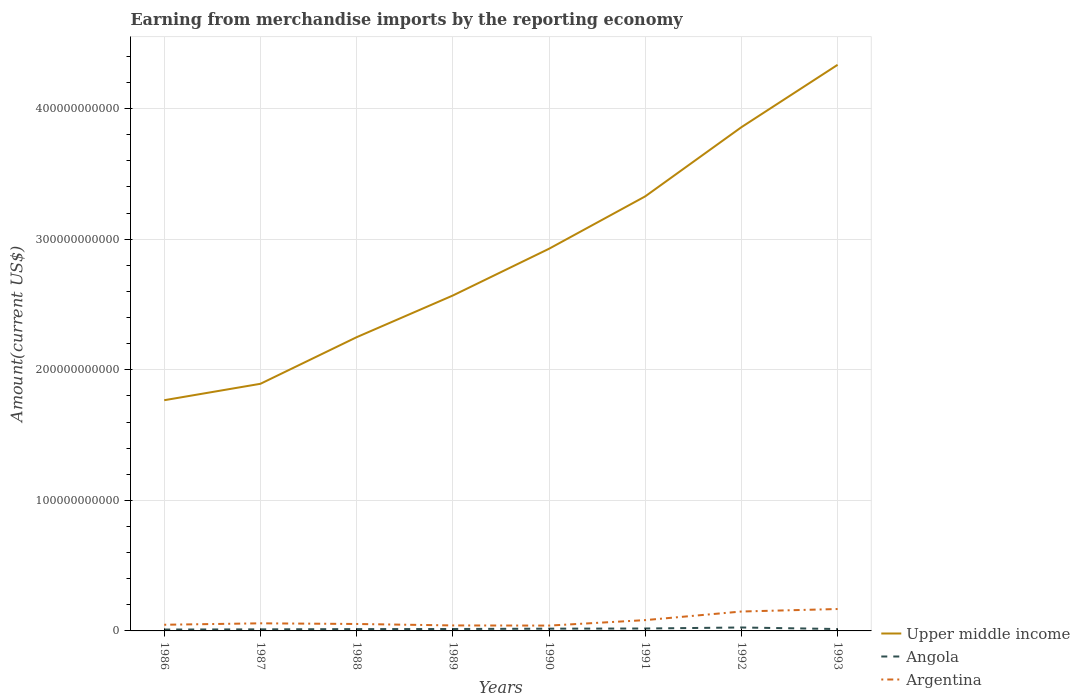How many different coloured lines are there?
Offer a very short reply. 3. Across all years, what is the maximum amount earned from merchandise imports in Angola?
Give a very brief answer. 1.06e+09. In which year was the amount earned from merchandise imports in Argentina maximum?
Ensure brevity in your answer.  1990. What is the total amount earned from merchandise imports in Upper middle income in the graph?
Make the answer very short. -6.76e+1. What is the difference between the highest and the second highest amount earned from merchandise imports in Argentina?
Provide a succinct answer. 1.27e+1. How many lines are there?
Provide a short and direct response. 3. What is the difference between two consecutive major ticks on the Y-axis?
Give a very brief answer. 1.00e+11. Are the values on the major ticks of Y-axis written in scientific E-notation?
Your answer should be compact. No. Does the graph contain any zero values?
Offer a very short reply. No. Does the graph contain grids?
Offer a very short reply. Yes. Where does the legend appear in the graph?
Offer a very short reply. Bottom right. How are the legend labels stacked?
Offer a very short reply. Vertical. What is the title of the graph?
Your response must be concise. Earning from merchandise imports by the reporting economy. Does "Peru" appear as one of the legend labels in the graph?
Offer a very short reply. No. What is the label or title of the X-axis?
Your response must be concise. Years. What is the label or title of the Y-axis?
Your answer should be compact. Amount(current US$). What is the Amount(current US$) in Upper middle income in 1986?
Ensure brevity in your answer.  1.77e+11. What is the Amount(current US$) in Angola in 1986?
Your response must be concise. 1.06e+09. What is the Amount(current US$) in Argentina in 1986?
Keep it short and to the point. 4.72e+09. What is the Amount(current US$) in Upper middle income in 1987?
Provide a succinct answer. 1.89e+11. What is the Amount(current US$) of Angola in 1987?
Provide a succinct answer. 1.20e+09. What is the Amount(current US$) of Argentina in 1987?
Your answer should be very brief. 5.82e+09. What is the Amount(current US$) in Upper middle income in 1988?
Keep it short and to the point. 2.25e+11. What is the Amount(current US$) in Angola in 1988?
Offer a terse response. 1.40e+09. What is the Amount(current US$) in Argentina in 1988?
Make the answer very short. 5.32e+09. What is the Amount(current US$) in Upper middle income in 1989?
Make the answer very short. 2.57e+11. What is the Amount(current US$) in Angola in 1989?
Offer a very short reply. 1.47e+09. What is the Amount(current US$) of Argentina in 1989?
Offer a terse response. 4.20e+09. What is the Amount(current US$) of Upper middle income in 1990?
Your answer should be very brief. 2.93e+11. What is the Amount(current US$) of Angola in 1990?
Provide a succinct answer. 1.72e+09. What is the Amount(current US$) of Argentina in 1990?
Offer a terse response. 4.08e+09. What is the Amount(current US$) in Upper middle income in 1991?
Your answer should be compact. 3.33e+11. What is the Amount(current US$) of Angola in 1991?
Ensure brevity in your answer.  1.85e+09. What is the Amount(current US$) in Argentina in 1991?
Ensure brevity in your answer.  8.28e+09. What is the Amount(current US$) of Upper middle income in 1992?
Provide a short and direct response. 3.86e+11. What is the Amount(current US$) of Angola in 1992?
Your answer should be very brief. 2.63e+09. What is the Amount(current US$) of Argentina in 1992?
Provide a short and direct response. 1.49e+1. What is the Amount(current US$) in Upper middle income in 1993?
Your response must be concise. 4.34e+11. What is the Amount(current US$) of Angola in 1993?
Your answer should be very brief. 1.45e+09. What is the Amount(current US$) in Argentina in 1993?
Provide a succinct answer. 1.68e+1. Across all years, what is the maximum Amount(current US$) of Upper middle income?
Provide a succinct answer. 4.34e+11. Across all years, what is the maximum Amount(current US$) in Angola?
Your response must be concise. 2.63e+09. Across all years, what is the maximum Amount(current US$) in Argentina?
Your answer should be compact. 1.68e+1. Across all years, what is the minimum Amount(current US$) of Upper middle income?
Offer a terse response. 1.77e+11. Across all years, what is the minimum Amount(current US$) in Angola?
Your answer should be compact. 1.06e+09. Across all years, what is the minimum Amount(current US$) in Argentina?
Give a very brief answer. 4.08e+09. What is the total Amount(current US$) in Upper middle income in the graph?
Provide a succinct answer. 2.29e+12. What is the total Amount(current US$) of Angola in the graph?
Provide a short and direct response. 1.28e+1. What is the total Amount(current US$) of Argentina in the graph?
Your answer should be very brief. 6.41e+1. What is the difference between the Amount(current US$) in Upper middle income in 1986 and that in 1987?
Keep it short and to the point. -1.26e+1. What is the difference between the Amount(current US$) of Angola in 1986 and that in 1987?
Offer a very short reply. -1.47e+08. What is the difference between the Amount(current US$) in Argentina in 1986 and that in 1987?
Make the answer very short. -1.09e+09. What is the difference between the Amount(current US$) in Upper middle income in 1986 and that in 1988?
Provide a succinct answer. -4.83e+1. What is the difference between the Amount(current US$) in Angola in 1986 and that in 1988?
Make the answer very short. -3.39e+08. What is the difference between the Amount(current US$) of Argentina in 1986 and that in 1988?
Your response must be concise. -5.95e+08. What is the difference between the Amount(current US$) of Upper middle income in 1986 and that in 1989?
Offer a terse response. -8.02e+1. What is the difference between the Amount(current US$) in Angola in 1986 and that in 1989?
Your answer should be compact. -4.11e+08. What is the difference between the Amount(current US$) in Argentina in 1986 and that in 1989?
Provide a succinct answer. 5.24e+08. What is the difference between the Amount(current US$) in Upper middle income in 1986 and that in 1990?
Your answer should be very brief. -1.16e+11. What is the difference between the Amount(current US$) in Angola in 1986 and that in 1990?
Offer a terse response. -6.65e+08. What is the difference between the Amount(current US$) in Argentina in 1986 and that in 1990?
Provide a short and direct response. 6.46e+08. What is the difference between the Amount(current US$) in Upper middle income in 1986 and that in 1991?
Provide a short and direct response. -1.56e+11. What is the difference between the Amount(current US$) in Angola in 1986 and that in 1991?
Offer a terse response. -7.89e+08. What is the difference between the Amount(current US$) in Argentina in 1986 and that in 1991?
Give a very brief answer. -3.55e+09. What is the difference between the Amount(current US$) in Upper middle income in 1986 and that in 1992?
Make the answer very short. -2.09e+11. What is the difference between the Amount(current US$) in Angola in 1986 and that in 1992?
Offer a terse response. -1.57e+09. What is the difference between the Amount(current US$) in Argentina in 1986 and that in 1992?
Ensure brevity in your answer.  -1.01e+1. What is the difference between the Amount(current US$) of Upper middle income in 1986 and that in 1993?
Your answer should be very brief. -2.57e+11. What is the difference between the Amount(current US$) of Angola in 1986 and that in 1993?
Offer a very short reply. -3.93e+08. What is the difference between the Amount(current US$) of Argentina in 1986 and that in 1993?
Keep it short and to the point. -1.20e+1. What is the difference between the Amount(current US$) in Upper middle income in 1987 and that in 1988?
Offer a terse response. -3.57e+1. What is the difference between the Amount(current US$) in Angola in 1987 and that in 1988?
Provide a short and direct response. -1.92e+08. What is the difference between the Amount(current US$) in Argentina in 1987 and that in 1988?
Offer a terse response. 4.99e+08. What is the difference between the Amount(current US$) of Upper middle income in 1987 and that in 1989?
Your response must be concise. -6.76e+1. What is the difference between the Amount(current US$) of Angola in 1987 and that in 1989?
Give a very brief answer. -2.64e+08. What is the difference between the Amount(current US$) of Argentina in 1987 and that in 1989?
Ensure brevity in your answer.  1.62e+09. What is the difference between the Amount(current US$) in Upper middle income in 1987 and that in 1990?
Make the answer very short. -1.03e+11. What is the difference between the Amount(current US$) of Angola in 1987 and that in 1990?
Make the answer very short. -5.18e+08. What is the difference between the Amount(current US$) of Argentina in 1987 and that in 1990?
Provide a succinct answer. 1.74e+09. What is the difference between the Amount(current US$) of Upper middle income in 1987 and that in 1991?
Make the answer very short. -1.44e+11. What is the difference between the Amount(current US$) in Angola in 1987 and that in 1991?
Offer a terse response. -6.42e+08. What is the difference between the Amount(current US$) of Argentina in 1987 and that in 1991?
Your answer should be very brief. -2.46e+09. What is the difference between the Amount(current US$) in Upper middle income in 1987 and that in 1992?
Make the answer very short. -1.97e+11. What is the difference between the Amount(current US$) of Angola in 1987 and that in 1992?
Provide a succinct answer. -1.43e+09. What is the difference between the Amount(current US$) of Argentina in 1987 and that in 1992?
Your answer should be very brief. -9.04e+09. What is the difference between the Amount(current US$) in Upper middle income in 1987 and that in 1993?
Offer a very short reply. -2.44e+11. What is the difference between the Amount(current US$) of Angola in 1987 and that in 1993?
Give a very brief answer. -2.46e+08. What is the difference between the Amount(current US$) of Argentina in 1987 and that in 1993?
Make the answer very short. -1.10e+1. What is the difference between the Amount(current US$) of Upper middle income in 1988 and that in 1989?
Provide a succinct answer. -3.19e+1. What is the difference between the Amount(current US$) of Angola in 1988 and that in 1989?
Provide a short and direct response. -7.23e+07. What is the difference between the Amount(current US$) in Argentina in 1988 and that in 1989?
Ensure brevity in your answer.  1.12e+09. What is the difference between the Amount(current US$) of Upper middle income in 1988 and that in 1990?
Your answer should be very brief. -6.77e+1. What is the difference between the Amount(current US$) of Angola in 1988 and that in 1990?
Make the answer very short. -3.27e+08. What is the difference between the Amount(current US$) of Argentina in 1988 and that in 1990?
Ensure brevity in your answer.  1.24e+09. What is the difference between the Amount(current US$) of Upper middle income in 1988 and that in 1991?
Provide a short and direct response. -1.08e+11. What is the difference between the Amount(current US$) in Angola in 1988 and that in 1991?
Your answer should be compact. -4.50e+08. What is the difference between the Amount(current US$) in Argentina in 1988 and that in 1991?
Give a very brief answer. -2.96e+09. What is the difference between the Amount(current US$) of Upper middle income in 1988 and that in 1992?
Provide a succinct answer. -1.61e+11. What is the difference between the Amount(current US$) of Angola in 1988 and that in 1992?
Keep it short and to the point. -1.24e+09. What is the difference between the Amount(current US$) of Argentina in 1988 and that in 1992?
Give a very brief answer. -9.54e+09. What is the difference between the Amount(current US$) of Upper middle income in 1988 and that in 1993?
Your answer should be compact. -2.09e+11. What is the difference between the Amount(current US$) of Angola in 1988 and that in 1993?
Your answer should be very brief. -5.45e+07. What is the difference between the Amount(current US$) in Argentina in 1988 and that in 1993?
Give a very brief answer. -1.15e+1. What is the difference between the Amount(current US$) in Upper middle income in 1989 and that in 1990?
Your answer should be compact. -3.58e+1. What is the difference between the Amount(current US$) in Angola in 1989 and that in 1990?
Your answer should be compact. -2.54e+08. What is the difference between the Amount(current US$) of Argentina in 1989 and that in 1990?
Ensure brevity in your answer.  1.22e+08. What is the difference between the Amount(current US$) of Upper middle income in 1989 and that in 1991?
Provide a short and direct response. -7.59e+1. What is the difference between the Amount(current US$) of Angola in 1989 and that in 1991?
Offer a terse response. -3.78e+08. What is the difference between the Amount(current US$) in Argentina in 1989 and that in 1991?
Provide a succinct answer. -4.07e+09. What is the difference between the Amount(current US$) in Upper middle income in 1989 and that in 1992?
Your answer should be compact. -1.29e+11. What is the difference between the Amount(current US$) in Angola in 1989 and that in 1992?
Your answer should be compact. -1.16e+09. What is the difference between the Amount(current US$) of Argentina in 1989 and that in 1992?
Keep it short and to the point. -1.07e+1. What is the difference between the Amount(current US$) of Upper middle income in 1989 and that in 1993?
Keep it short and to the point. -1.77e+11. What is the difference between the Amount(current US$) of Angola in 1989 and that in 1993?
Your response must be concise. 1.78e+07. What is the difference between the Amount(current US$) of Argentina in 1989 and that in 1993?
Ensure brevity in your answer.  -1.26e+1. What is the difference between the Amount(current US$) in Upper middle income in 1990 and that in 1991?
Keep it short and to the point. -4.01e+1. What is the difference between the Amount(current US$) in Angola in 1990 and that in 1991?
Your response must be concise. -1.24e+08. What is the difference between the Amount(current US$) of Argentina in 1990 and that in 1991?
Your answer should be very brief. -4.20e+09. What is the difference between the Amount(current US$) of Upper middle income in 1990 and that in 1992?
Make the answer very short. -9.31e+1. What is the difference between the Amount(current US$) in Angola in 1990 and that in 1992?
Provide a short and direct response. -9.10e+08. What is the difference between the Amount(current US$) in Argentina in 1990 and that in 1992?
Your answer should be very brief. -1.08e+1. What is the difference between the Amount(current US$) in Upper middle income in 1990 and that in 1993?
Make the answer very short. -1.41e+11. What is the difference between the Amount(current US$) of Angola in 1990 and that in 1993?
Make the answer very short. 2.72e+08. What is the difference between the Amount(current US$) in Argentina in 1990 and that in 1993?
Offer a terse response. -1.27e+1. What is the difference between the Amount(current US$) of Upper middle income in 1991 and that in 1992?
Make the answer very short. -5.30e+1. What is the difference between the Amount(current US$) in Angola in 1991 and that in 1992?
Your response must be concise. -7.86e+08. What is the difference between the Amount(current US$) in Argentina in 1991 and that in 1992?
Offer a terse response. -6.59e+09. What is the difference between the Amount(current US$) in Upper middle income in 1991 and that in 1993?
Ensure brevity in your answer.  -1.01e+11. What is the difference between the Amount(current US$) in Angola in 1991 and that in 1993?
Give a very brief answer. 3.96e+08. What is the difference between the Amount(current US$) in Argentina in 1991 and that in 1993?
Ensure brevity in your answer.  -8.50e+09. What is the difference between the Amount(current US$) of Upper middle income in 1992 and that in 1993?
Offer a terse response. -4.78e+1. What is the difference between the Amount(current US$) of Angola in 1992 and that in 1993?
Offer a very short reply. 1.18e+09. What is the difference between the Amount(current US$) of Argentina in 1992 and that in 1993?
Your response must be concise. -1.91e+09. What is the difference between the Amount(current US$) of Upper middle income in 1986 and the Amount(current US$) of Angola in 1987?
Offer a very short reply. 1.75e+11. What is the difference between the Amount(current US$) of Upper middle income in 1986 and the Amount(current US$) of Argentina in 1987?
Your response must be concise. 1.71e+11. What is the difference between the Amount(current US$) in Angola in 1986 and the Amount(current US$) in Argentina in 1987?
Offer a terse response. -4.76e+09. What is the difference between the Amount(current US$) of Upper middle income in 1986 and the Amount(current US$) of Angola in 1988?
Provide a short and direct response. 1.75e+11. What is the difference between the Amount(current US$) of Upper middle income in 1986 and the Amount(current US$) of Argentina in 1988?
Make the answer very short. 1.71e+11. What is the difference between the Amount(current US$) of Angola in 1986 and the Amount(current US$) of Argentina in 1988?
Provide a succinct answer. -4.26e+09. What is the difference between the Amount(current US$) in Upper middle income in 1986 and the Amount(current US$) in Angola in 1989?
Ensure brevity in your answer.  1.75e+11. What is the difference between the Amount(current US$) in Upper middle income in 1986 and the Amount(current US$) in Argentina in 1989?
Offer a terse response. 1.72e+11. What is the difference between the Amount(current US$) of Angola in 1986 and the Amount(current US$) of Argentina in 1989?
Make the answer very short. -3.14e+09. What is the difference between the Amount(current US$) of Upper middle income in 1986 and the Amount(current US$) of Angola in 1990?
Make the answer very short. 1.75e+11. What is the difference between the Amount(current US$) of Upper middle income in 1986 and the Amount(current US$) of Argentina in 1990?
Keep it short and to the point. 1.73e+11. What is the difference between the Amount(current US$) in Angola in 1986 and the Amount(current US$) in Argentina in 1990?
Keep it short and to the point. -3.02e+09. What is the difference between the Amount(current US$) in Upper middle income in 1986 and the Amount(current US$) in Angola in 1991?
Keep it short and to the point. 1.75e+11. What is the difference between the Amount(current US$) in Upper middle income in 1986 and the Amount(current US$) in Argentina in 1991?
Your response must be concise. 1.68e+11. What is the difference between the Amount(current US$) in Angola in 1986 and the Amount(current US$) in Argentina in 1991?
Your response must be concise. -7.22e+09. What is the difference between the Amount(current US$) in Upper middle income in 1986 and the Amount(current US$) in Angola in 1992?
Keep it short and to the point. 1.74e+11. What is the difference between the Amount(current US$) in Upper middle income in 1986 and the Amount(current US$) in Argentina in 1992?
Your answer should be compact. 1.62e+11. What is the difference between the Amount(current US$) in Angola in 1986 and the Amount(current US$) in Argentina in 1992?
Ensure brevity in your answer.  -1.38e+1. What is the difference between the Amount(current US$) in Upper middle income in 1986 and the Amount(current US$) in Angola in 1993?
Offer a very short reply. 1.75e+11. What is the difference between the Amount(current US$) of Upper middle income in 1986 and the Amount(current US$) of Argentina in 1993?
Provide a succinct answer. 1.60e+11. What is the difference between the Amount(current US$) of Angola in 1986 and the Amount(current US$) of Argentina in 1993?
Your answer should be compact. -1.57e+1. What is the difference between the Amount(current US$) in Upper middle income in 1987 and the Amount(current US$) in Angola in 1988?
Your answer should be compact. 1.88e+11. What is the difference between the Amount(current US$) in Upper middle income in 1987 and the Amount(current US$) in Argentina in 1988?
Your answer should be compact. 1.84e+11. What is the difference between the Amount(current US$) in Angola in 1987 and the Amount(current US$) in Argentina in 1988?
Provide a succinct answer. -4.11e+09. What is the difference between the Amount(current US$) of Upper middle income in 1987 and the Amount(current US$) of Angola in 1989?
Keep it short and to the point. 1.88e+11. What is the difference between the Amount(current US$) of Upper middle income in 1987 and the Amount(current US$) of Argentina in 1989?
Keep it short and to the point. 1.85e+11. What is the difference between the Amount(current US$) of Angola in 1987 and the Amount(current US$) of Argentina in 1989?
Your answer should be very brief. -3.00e+09. What is the difference between the Amount(current US$) of Upper middle income in 1987 and the Amount(current US$) of Angola in 1990?
Provide a short and direct response. 1.88e+11. What is the difference between the Amount(current US$) of Upper middle income in 1987 and the Amount(current US$) of Argentina in 1990?
Provide a succinct answer. 1.85e+11. What is the difference between the Amount(current US$) of Angola in 1987 and the Amount(current US$) of Argentina in 1990?
Offer a terse response. -2.87e+09. What is the difference between the Amount(current US$) of Upper middle income in 1987 and the Amount(current US$) of Angola in 1991?
Offer a very short reply. 1.87e+11. What is the difference between the Amount(current US$) of Upper middle income in 1987 and the Amount(current US$) of Argentina in 1991?
Your answer should be compact. 1.81e+11. What is the difference between the Amount(current US$) of Angola in 1987 and the Amount(current US$) of Argentina in 1991?
Your response must be concise. -7.07e+09. What is the difference between the Amount(current US$) of Upper middle income in 1987 and the Amount(current US$) of Angola in 1992?
Provide a short and direct response. 1.87e+11. What is the difference between the Amount(current US$) of Upper middle income in 1987 and the Amount(current US$) of Argentina in 1992?
Keep it short and to the point. 1.74e+11. What is the difference between the Amount(current US$) of Angola in 1987 and the Amount(current US$) of Argentina in 1992?
Offer a terse response. -1.37e+1. What is the difference between the Amount(current US$) in Upper middle income in 1987 and the Amount(current US$) in Angola in 1993?
Your response must be concise. 1.88e+11. What is the difference between the Amount(current US$) in Upper middle income in 1987 and the Amount(current US$) in Argentina in 1993?
Provide a succinct answer. 1.72e+11. What is the difference between the Amount(current US$) of Angola in 1987 and the Amount(current US$) of Argentina in 1993?
Ensure brevity in your answer.  -1.56e+1. What is the difference between the Amount(current US$) in Upper middle income in 1988 and the Amount(current US$) in Angola in 1989?
Make the answer very short. 2.23e+11. What is the difference between the Amount(current US$) of Upper middle income in 1988 and the Amount(current US$) of Argentina in 1989?
Your response must be concise. 2.21e+11. What is the difference between the Amount(current US$) of Angola in 1988 and the Amount(current US$) of Argentina in 1989?
Offer a very short reply. -2.80e+09. What is the difference between the Amount(current US$) in Upper middle income in 1988 and the Amount(current US$) in Angola in 1990?
Your answer should be very brief. 2.23e+11. What is the difference between the Amount(current US$) of Upper middle income in 1988 and the Amount(current US$) of Argentina in 1990?
Provide a succinct answer. 2.21e+11. What is the difference between the Amount(current US$) of Angola in 1988 and the Amount(current US$) of Argentina in 1990?
Your response must be concise. -2.68e+09. What is the difference between the Amount(current US$) in Upper middle income in 1988 and the Amount(current US$) in Angola in 1991?
Your answer should be very brief. 2.23e+11. What is the difference between the Amount(current US$) of Upper middle income in 1988 and the Amount(current US$) of Argentina in 1991?
Your response must be concise. 2.17e+11. What is the difference between the Amount(current US$) of Angola in 1988 and the Amount(current US$) of Argentina in 1991?
Offer a very short reply. -6.88e+09. What is the difference between the Amount(current US$) of Upper middle income in 1988 and the Amount(current US$) of Angola in 1992?
Provide a short and direct response. 2.22e+11. What is the difference between the Amount(current US$) in Upper middle income in 1988 and the Amount(current US$) in Argentina in 1992?
Your answer should be very brief. 2.10e+11. What is the difference between the Amount(current US$) of Angola in 1988 and the Amount(current US$) of Argentina in 1992?
Give a very brief answer. -1.35e+1. What is the difference between the Amount(current US$) in Upper middle income in 1988 and the Amount(current US$) in Angola in 1993?
Keep it short and to the point. 2.23e+11. What is the difference between the Amount(current US$) of Upper middle income in 1988 and the Amount(current US$) of Argentina in 1993?
Offer a terse response. 2.08e+11. What is the difference between the Amount(current US$) of Angola in 1988 and the Amount(current US$) of Argentina in 1993?
Provide a short and direct response. -1.54e+1. What is the difference between the Amount(current US$) in Upper middle income in 1989 and the Amount(current US$) in Angola in 1990?
Provide a short and direct response. 2.55e+11. What is the difference between the Amount(current US$) of Upper middle income in 1989 and the Amount(current US$) of Argentina in 1990?
Provide a short and direct response. 2.53e+11. What is the difference between the Amount(current US$) in Angola in 1989 and the Amount(current US$) in Argentina in 1990?
Provide a succinct answer. -2.61e+09. What is the difference between the Amount(current US$) in Upper middle income in 1989 and the Amount(current US$) in Angola in 1991?
Provide a short and direct response. 2.55e+11. What is the difference between the Amount(current US$) in Upper middle income in 1989 and the Amount(current US$) in Argentina in 1991?
Your answer should be compact. 2.49e+11. What is the difference between the Amount(current US$) in Angola in 1989 and the Amount(current US$) in Argentina in 1991?
Your response must be concise. -6.81e+09. What is the difference between the Amount(current US$) in Upper middle income in 1989 and the Amount(current US$) in Angola in 1992?
Provide a short and direct response. 2.54e+11. What is the difference between the Amount(current US$) of Upper middle income in 1989 and the Amount(current US$) of Argentina in 1992?
Offer a very short reply. 2.42e+11. What is the difference between the Amount(current US$) of Angola in 1989 and the Amount(current US$) of Argentina in 1992?
Your response must be concise. -1.34e+1. What is the difference between the Amount(current US$) of Upper middle income in 1989 and the Amount(current US$) of Angola in 1993?
Keep it short and to the point. 2.55e+11. What is the difference between the Amount(current US$) of Upper middle income in 1989 and the Amount(current US$) of Argentina in 1993?
Make the answer very short. 2.40e+11. What is the difference between the Amount(current US$) of Angola in 1989 and the Amount(current US$) of Argentina in 1993?
Offer a very short reply. -1.53e+1. What is the difference between the Amount(current US$) of Upper middle income in 1990 and the Amount(current US$) of Angola in 1991?
Provide a short and direct response. 2.91e+11. What is the difference between the Amount(current US$) of Upper middle income in 1990 and the Amount(current US$) of Argentina in 1991?
Ensure brevity in your answer.  2.84e+11. What is the difference between the Amount(current US$) of Angola in 1990 and the Amount(current US$) of Argentina in 1991?
Give a very brief answer. -6.55e+09. What is the difference between the Amount(current US$) in Upper middle income in 1990 and the Amount(current US$) in Angola in 1992?
Your answer should be very brief. 2.90e+11. What is the difference between the Amount(current US$) in Upper middle income in 1990 and the Amount(current US$) in Argentina in 1992?
Ensure brevity in your answer.  2.78e+11. What is the difference between the Amount(current US$) of Angola in 1990 and the Amount(current US$) of Argentina in 1992?
Your answer should be very brief. -1.31e+1. What is the difference between the Amount(current US$) of Upper middle income in 1990 and the Amount(current US$) of Angola in 1993?
Offer a terse response. 2.91e+11. What is the difference between the Amount(current US$) of Upper middle income in 1990 and the Amount(current US$) of Argentina in 1993?
Give a very brief answer. 2.76e+11. What is the difference between the Amount(current US$) of Angola in 1990 and the Amount(current US$) of Argentina in 1993?
Offer a terse response. -1.51e+1. What is the difference between the Amount(current US$) in Upper middle income in 1991 and the Amount(current US$) in Angola in 1992?
Make the answer very short. 3.30e+11. What is the difference between the Amount(current US$) in Upper middle income in 1991 and the Amount(current US$) in Argentina in 1992?
Give a very brief answer. 3.18e+11. What is the difference between the Amount(current US$) of Angola in 1991 and the Amount(current US$) of Argentina in 1992?
Your answer should be compact. -1.30e+1. What is the difference between the Amount(current US$) of Upper middle income in 1991 and the Amount(current US$) of Angola in 1993?
Your response must be concise. 3.31e+11. What is the difference between the Amount(current US$) of Upper middle income in 1991 and the Amount(current US$) of Argentina in 1993?
Give a very brief answer. 3.16e+11. What is the difference between the Amount(current US$) of Angola in 1991 and the Amount(current US$) of Argentina in 1993?
Keep it short and to the point. -1.49e+1. What is the difference between the Amount(current US$) in Upper middle income in 1992 and the Amount(current US$) in Angola in 1993?
Your answer should be compact. 3.84e+11. What is the difference between the Amount(current US$) of Upper middle income in 1992 and the Amount(current US$) of Argentina in 1993?
Provide a short and direct response. 3.69e+11. What is the difference between the Amount(current US$) in Angola in 1992 and the Amount(current US$) in Argentina in 1993?
Your response must be concise. -1.41e+1. What is the average Amount(current US$) in Upper middle income per year?
Give a very brief answer. 2.87e+11. What is the average Amount(current US$) of Angola per year?
Offer a terse response. 1.60e+09. What is the average Amount(current US$) in Argentina per year?
Make the answer very short. 8.01e+09. In the year 1986, what is the difference between the Amount(current US$) in Upper middle income and Amount(current US$) in Angola?
Give a very brief answer. 1.76e+11. In the year 1986, what is the difference between the Amount(current US$) in Upper middle income and Amount(current US$) in Argentina?
Offer a very short reply. 1.72e+11. In the year 1986, what is the difference between the Amount(current US$) of Angola and Amount(current US$) of Argentina?
Make the answer very short. -3.67e+09. In the year 1987, what is the difference between the Amount(current US$) of Upper middle income and Amount(current US$) of Angola?
Offer a very short reply. 1.88e+11. In the year 1987, what is the difference between the Amount(current US$) of Upper middle income and Amount(current US$) of Argentina?
Offer a terse response. 1.83e+11. In the year 1987, what is the difference between the Amount(current US$) of Angola and Amount(current US$) of Argentina?
Your answer should be very brief. -4.61e+09. In the year 1988, what is the difference between the Amount(current US$) in Upper middle income and Amount(current US$) in Angola?
Keep it short and to the point. 2.24e+11. In the year 1988, what is the difference between the Amount(current US$) in Upper middle income and Amount(current US$) in Argentina?
Your answer should be very brief. 2.20e+11. In the year 1988, what is the difference between the Amount(current US$) of Angola and Amount(current US$) of Argentina?
Make the answer very short. -3.92e+09. In the year 1989, what is the difference between the Amount(current US$) in Upper middle income and Amount(current US$) in Angola?
Provide a short and direct response. 2.55e+11. In the year 1989, what is the difference between the Amount(current US$) in Upper middle income and Amount(current US$) in Argentina?
Provide a succinct answer. 2.53e+11. In the year 1989, what is the difference between the Amount(current US$) in Angola and Amount(current US$) in Argentina?
Offer a very short reply. -2.73e+09. In the year 1990, what is the difference between the Amount(current US$) in Upper middle income and Amount(current US$) in Angola?
Your response must be concise. 2.91e+11. In the year 1990, what is the difference between the Amount(current US$) in Upper middle income and Amount(current US$) in Argentina?
Make the answer very short. 2.89e+11. In the year 1990, what is the difference between the Amount(current US$) in Angola and Amount(current US$) in Argentina?
Offer a terse response. -2.36e+09. In the year 1991, what is the difference between the Amount(current US$) in Upper middle income and Amount(current US$) in Angola?
Offer a terse response. 3.31e+11. In the year 1991, what is the difference between the Amount(current US$) of Upper middle income and Amount(current US$) of Argentina?
Keep it short and to the point. 3.25e+11. In the year 1991, what is the difference between the Amount(current US$) in Angola and Amount(current US$) in Argentina?
Your answer should be very brief. -6.43e+09. In the year 1992, what is the difference between the Amount(current US$) of Upper middle income and Amount(current US$) of Angola?
Offer a terse response. 3.83e+11. In the year 1992, what is the difference between the Amount(current US$) of Upper middle income and Amount(current US$) of Argentina?
Give a very brief answer. 3.71e+11. In the year 1992, what is the difference between the Amount(current US$) of Angola and Amount(current US$) of Argentina?
Ensure brevity in your answer.  -1.22e+1. In the year 1993, what is the difference between the Amount(current US$) in Upper middle income and Amount(current US$) in Angola?
Make the answer very short. 4.32e+11. In the year 1993, what is the difference between the Amount(current US$) in Upper middle income and Amount(current US$) in Argentina?
Ensure brevity in your answer.  4.17e+11. In the year 1993, what is the difference between the Amount(current US$) in Angola and Amount(current US$) in Argentina?
Your response must be concise. -1.53e+1. What is the ratio of the Amount(current US$) of Upper middle income in 1986 to that in 1987?
Offer a very short reply. 0.93. What is the ratio of the Amount(current US$) in Angola in 1986 to that in 1987?
Your answer should be very brief. 0.88. What is the ratio of the Amount(current US$) in Argentina in 1986 to that in 1987?
Keep it short and to the point. 0.81. What is the ratio of the Amount(current US$) of Upper middle income in 1986 to that in 1988?
Offer a very short reply. 0.79. What is the ratio of the Amount(current US$) of Angola in 1986 to that in 1988?
Offer a terse response. 0.76. What is the ratio of the Amount(current US$) in Argentina in 1986 to that in 1988?
Offer a very short reply. 0.89. What is the ratio of the Amount(current US$) in Upper middle income in 1986 to that in 1989?
Make the answer very short. 0.69. What is the ratio of the Amount(current US$) in Angola in 1986 to that in 1989?
Make the answer very short. 0.72. What is the ratio of the Amount(current US$) of Argentina in 1986 to that in 1989?
Offer a very short reply. 1.12. What is the ratio of the Amount(current US$) in Upper middle income in 1986 to that in 1990?
Keep it short and to the point. 0.6. What is the ratio of the Amount(current US$) of Angola in 1986 to that in 1990?
Provide a succinct answer. 0.61. What is the ratio of the Amount(current US$) in Argentina in 1986 to that in 1990?
Provide a short and direct response. 1.16. What is the ratio of the Amount(current US$) in Upper middle income in 1986 to that in 1991?
Provide a succinct answer. 0.53. What is the ratio of the Amount(current US$) in Angola in 1986 to that in 1991?
Keep it short and to the point. 0.57. What is the ratio of the Amount(current US$) of Argentina in 1986 to that in 1991?
Keep it short and to the point. 0.57. What is the ratio of the Amount(current US$) of Upper middle income in 1986 to that in 1992?
Offer a terse response. 0.46. What is the ratio of the Amount(current US$) in Angola in 1986 to that in 1992?
Your answer should be compact. 0.4. What is the ratio of the Amount(current US$) of Argentina in 1986 to that in 1992?
Your answer should be compact. 0.32. What is the ratio of the Amount(current US$) in Upper middle income in 1986 to that in 1993?
Make the answer very short. 0.41. What is the ratio of the Amount(current US$) in Angola in 1986 to that in 1993?
Provide a short and direct response. 0.73. What is the ratio of the Amount(current US$) of Argentina in 1986 to that in 1993?
Give a very brief answer. 0.28. What is the ratio of the Amount(current US$) of Upper middle income in 1987 to that in 1988?
Your answer should be compact. 0.84. What is the ratio of the Amount(current US$) of Angola in 1987 to that in 1988?
Your response must be concise. 0.86. What is the ratio of the Amount(current US$) in Argentina in 1987 to that in 1988?
Your answer should be very brief. 1.09. What is the ratio of the Amount(current US$) in Upper middle income in 1987 to that in 1989?
Your answer should be very brief. 0.74. What is the ratio of the Amount(current US$) of Angola in 1987 to that in 1989?
Your answer should be very brief. 0.82. What is the ratio of the Amount(current US$) of Argentina in 1987 to that in 1989?
Give a very brief answer. 1.39. What is the ratio of the Amount(current US$) in Upper middle income in 1987 to that in 1990?
Your answer should be very brief. 0.65. What is the ratio of the Amount(current US$) of Angola in 1987 to that in 1990?
Provide a short and direct response. 0.7. What is the ratio of the Amount(current US$) in Argentina in 1987 to that in 1990?
Your answer should be very brief. 1.43. What is the ratio of the Amount(current US$) of Upper middle income in 1987 to that in 1991?
Provide a short and direct response. 0.57. What is the ratio of the Amount(current US$) in Angola in 1987 to that in 1991?
Your answer should be very brief. 0.65. What is the ratio of the Amount(current US$) in Argentina in 1987 to that in 1991?
Your response must be concise. 0.7. What is the ratio of the Amount(current US$) of Upper middle income in 1987 to that in 1992?
Make the answer very short. 0.49. What is the ratio of the Amount(current US$) in Angola in 1987 to that in 1992?
Your response must be concise. 0.46. What is the ratio of the Amount(current US$) of Argentina in 1987 to that in 1992?
Your answer should be compact. 0.39. What is the ratio of the Amount(current US$) in Upper middle income in 1987 to that in 1993?
Provide a succinct answer. 0.44. What is the ratio of the Amount(current US$) of Angola in 1987 to that in 1993?
Your answer should be very brief. 0.83. What is the ratio of the Amount(current US$) of Argentina in 1987 to that in 1993?
Your answer should be compact. 0.35. What is the ratio of the Amount(current US$) of Upper middle income in 1988 to that in 1989?
Your response must be concise. 0.88. What is the ratio of the Amount(current US$) of Angola in 1988 to that in 1989?
Ensure brevity in your answer.  0.95. What is the ratio of the Amount(current US$) of Argentina in 1988 to that in 1989?
Offer a very short reply. 1.27. What is the ratio of the Amount(current US$) in Upper middle income in 1988 to that in 1990?
Make the answer very short. 0.77. What is the ratio of the Amount(current US$) of Angola in 1988 to that in 1990?
Ensure brevity in your answer.  0.81. What is the ratio of the Amount(current US$) in Argentina in 1988 to that in 1990?
Your response must be concise. 1.3. What is the ratio of the Amount(current US$) in Upper middle income in 1988 to that in 1991?
Your response must be concise. 0.68. What is the ratio of the Amount(current US$) in Angola in 1988 to that in 1991?
Your answer should be compact. 0.76. What is the ratio of the Amount(current US$) in Argentina in 1988 to that in 1991?
Give a very brief answer. 0.64. What is the ratio of the Amount(current US$) in Upper middle income in 1988 to that in 1992?
Your answer should be very brief. 0.58. What is the ratio of the Amount(current US$) of Angola in 1988 to that in 1992?
Ensure brevity in your answer.  0.53. What is the ratio of the Amount(current US$) in Argentina in 1988 to that in 1992?
Provide a short and direct response. 0.36. What is the ratio of the Amount(current US$) of Upper middle income in 1988 to that in 1993?
Offer a terse response. 0.52. What is the ratio of the Amount(current US$) of Angola in 1988 to that in 1993?
Your answer should be very brief. 0.96. What is the ratio of the Amount(current US$) of Argentina in 1988 to that in 1993?
Keep it short and to the point. 0.32. What is the ratio of the Amount(current US$) of Upper middle income in 1989 to that in 1990?
Provide a short and direct response. 0.88. What is the ratio of the Amount(current US$) of Angola in 1989 to that in 1990?
Keep it short and to the point. 0.85. What is the ratio of the Amount(current US$) in Argentina in 1989 to that in 1990?
Keep it short and to the point. 1.03. What is the ratio of the Amount(current US$) of Upper middle income in 1989 to that in 1991?
Provide a succinct answer. 0.77. What is the ratio of the Amount(current US$) of Angola in 1989 to that in 1991?
Ensure brevity in your answer.  0.8. What is the ratio of the Amount(current US$) in Argentina in 1989 to that in 1991?
Offer a very short reply. 0.51. What is the ratio of the Amount(current US$) of Upper middle income in 1989 to that in 1992?
Your answer should be compact. 0.67. What is the ratio of the Amount(current US$) in Angola in 1989 to that in 1992?
Offer a very short reply. 0.56. What is the ratio of the Amount(current US$) in Argentina in 1989 to that in 1992?
Your answer should be very brief. 0.28. What is the ratio of the Amount(current US$) in Upper middle income in 1989 to that in 1993?
Provide a short and direct response. 0.59. What is the ratio of the Amount(current US$) of Angola in 1989 to that in 1993?
Offer a terse response. 1.01. What is the ratio of the Amount(current US$) of Argentina in 1989 to that in 1993?
Make the answer very short. 0.25. What is the ratio of the Amount(current US$) in Upper middle income in 1990 to that in 1991?
Make the answer very short. 0.88. What is the ratio of the Amount(current US$) in Angola in 1990 to that in 1991?
Keep it short and to the point. 0.93. What is the ratio of the Amount(current US$) in Argentina in 1990 to that in 1991?
Make the answer very short. 0.49. What is the ratio of the Amount(current US$) of Upper middle income in 1990 to that in 1992?
Your answer should be compact. 0.76. What is the ratio of the Amount(current US$) in Angola in 1990 to that in 1992?
Your response must be concise. 0.65. What is the ratio of the Amount(current US$) in Argentina in 1990 to that in 1992?
Keep it short and to the point. 0.27. What is the ratio of the Amount(current US$) in Upper middle income in 1990 to that in 1993?
Your answer should be very brief. 0.68. What is the ratio of the Amount(current US$) in Angola in 1990 to that in 1993?
Provide a short and direct response. 1.19. What is the ratio of the Amount(current US$) of Argentina in 1990 to that in 1993?
Your answer should be very brief. 0.24. What is the ratio of the Amount(current US$) of Upper middle income in 1991 to that in 1992?
Offer a very short reply. 0.86. What is the ratio of the Amount(current US$) in Angola in 1991 to that in 1992?
Offer a very short reply. 0.7. What is the ratio of the Amount(current US$) in Argentina in 1991 to that in 1992?
Make the answer very short. 0.56. What is the ratio of the Amount(current US$) in Upper middle income in 1991 to that in 1993?
Your response must be concise. 0.77. What is the ratio of the Amount(current US$) of Angola in 1991 to that in 1993?
Offer a terse response. 1.27. What is the ratio of the Amount(current US$) in Argentina in 1991 to that in 1993?
Provide a succinct answer. 0.49. What is the ratio of the Amount(current US$) in Upper middle income in 1992 to that in 1993?
Offer a terse response. 0.89. What is the ratio of the Amount(current US$) of Angola in 1992 to that in 1993?
Your answer should be very brief. 1.81. What is the ratio of the Amount(current US$) of Argentina in 1992 to that in 1993?
Provide a short and direct response. 0.89. What is the difference between the highest and the second highest Amount(current US$) of Upper middle income?
Make the answer very short. 4.78e+1. What is the difference between the highest and the second highest Amount(current US$) of Angola?
Your response must be concise. 7.86e+08. What is the difference between the highest and the second highest Amount(current US$) in Argentina?
Your response must be concise. 1.91e+09. What is the difference between the highest and the lowest Amount(current US$) in Upper middle income?
Make the answer very short. 2.57e+11. What is the difference between the highest and the lowest Amount(current US$) of Angola?
Offer a terse response. 1.57e+09. What is the difference between the highest and the lowest Amount(current US$) of Argentina?
Your answer should be very brief. 1.27e+1. 